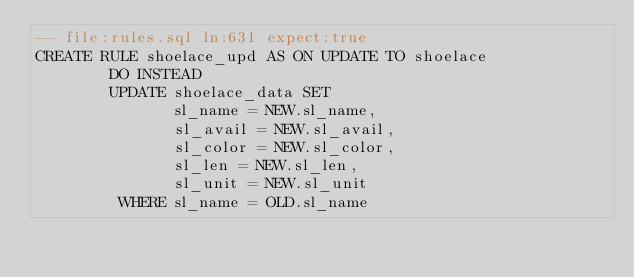<code> <loc_0><loc_0><loc_500><loc_500><_SQL_>-- file:rules.sql ln:631 expect:true
CREATE RULE shoelace_upd AS ON UPDATE TO shoelace
        DO INSTEAD
        UPDATE shoelace_data SET
               sl_name = NEW.sl_name,
               sl_avail = NEW.sl_avail,
               sl_color = NEW.sl_color,
               sl_len = NEW.sl_len,
               sl_unit = NEW.sl_unit
         WHERE sl_name = OLD.sl_name
</code> 